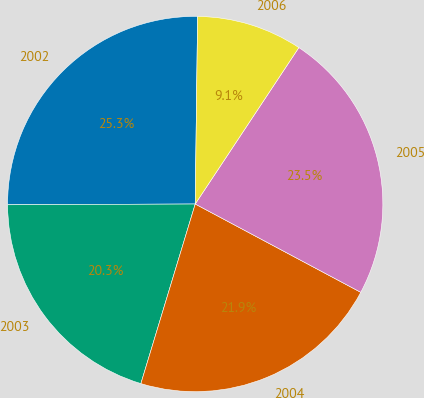Convert chart to OTSL. <chart><loc_0><loc_0><loc_500><loc_500><pie_chart><fcel>2002<fcel>2003<fcel>2004<fcel>2005<fcel>2006<nl><fcel>25.27%<fcel>20.26%<fcel>21.88%<fcel>23.49%<fcel>9.11%<nl></chart> 